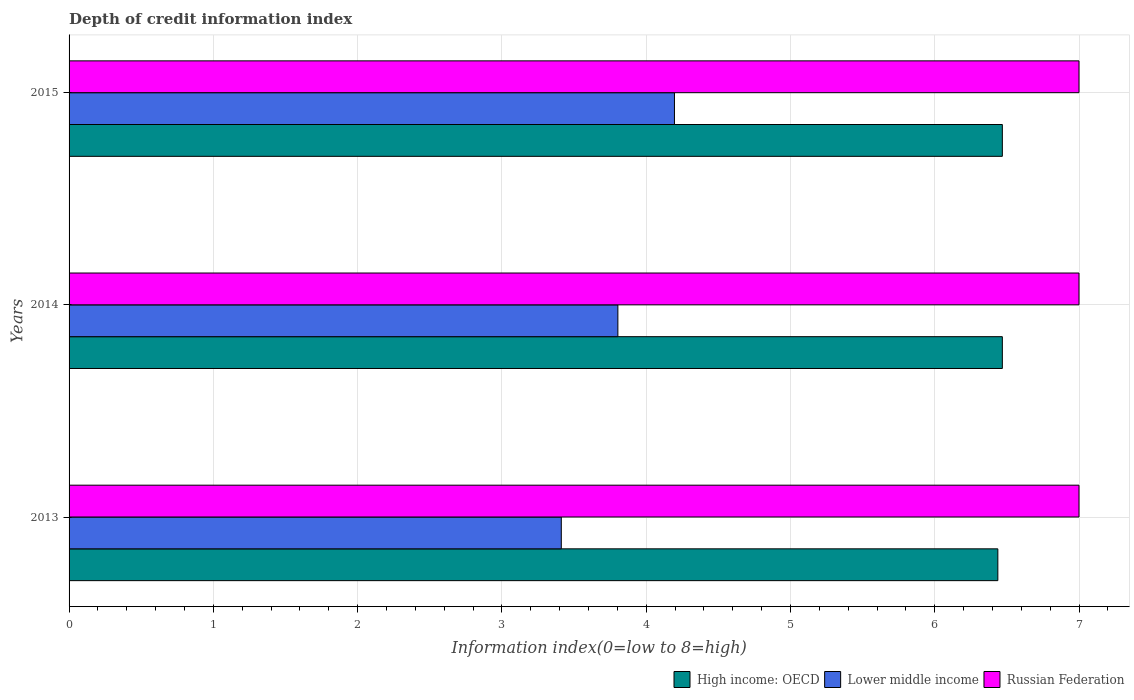How many groups of bars are there?
Provide a short and direct response. 3. Are the number of bars per tick equal to the number of legend labels?
Provide a short and direct response. Yes. Are the number of bars on each tick of the Y-axis equal?
Give a very brief answer. Yes. How many bars are there on the 3rd tick from the top?
Keep it short and to the point. 3. What is the information index in Russian Federation in 2013?
Your answer should be compact. 7. Across all years, what is the maximum information index in High income: OECD?
Keep it short and to the point. 6.47. Across all years, what is the minimum information index in Russian Federation?
Provide a succinct answer. 7. In which year was the information index in Lower middle income maximum?
Ensure brevity in your answer.  2015. In which year was the information index in Russian Federation minimum?
Provide a short and direct response. 2013. What is the total information index in High income: OECD in the graph?
Ensure brevity in your answer.  19.38. What is the difference between the information index in Lower middle income in 2014 and the information index in Russian Federation in 2013?
Your response must be concise. -3.2. What is the average information index in High income: OECD per year?
Keep it short and to the point. 6.46. In the year 2014, what is the difference between the information index in Lower middle income and information index in Russian Federation?
Offer a terse response. -3.2. In how many years, is the information index in High income: OECD greater than 5 ?
Keep it short and to the point. 3. What is the ratio of the information index in High income: OECD in 2013 to that in 2014?
Offer a terse response. 1. What is the difference between the highest and the lowest information index in Lower middle income?
Give a very brief answer. 0.78. What does the 2nd bar from the top in 2014 represents?
Your answer should be compact. Lower middle income. What does the 2nd bar from the bottom in 2013 represents?
Your response must be concise. Lower middle income. How many bars are there?
Ensure brevity in your answer.  9. Are all the bars in the graph horizontal?
Provide a succinct answer. Yes. What is the difference between two consecutive major ticks on the X-axis?
Your answer should be compact. 1. Are the values on the major ticks of X-axis written in scientific E-notation?
Offer a terse response. No. Does the graph contain any zero values?
Provide a short and direct response. No. How many legend labels are there?
Offer a terse response. 3. How are the legend labels stacked?
Give a very brief answer. Horizontal. What is the title of the graph?
Your answer should be compact. Depth of credit information index. Does "Cayman Islands" appear as one of the legend labels in the graph?
Your response must be concise. No. What is the label or title of the X-axis?
Ensure brevity in your answer.  Information index(0=low to 8=high). What is the Information index(0=low to 8=high) in High income: OECD in 2013?
Provide a succinct answer. 6.44. What is the Information index(0=low to 8=high) in Lower middle income in 2013?
Make the answer very short. 3.41. What is the Information index(0=low to 8=high) in High income: OECD in 2014?
Ensure brevity in your answer.  6.47. What is the Information index(0=low to 8=high) in Lower middle income in 2014?
Provide a short and direct response. 3.8. What is the Information index(0=low to 8=high) of Russian Federation in 2014?
Ensure brevity in your answer.  7. What is the Information index(0=low to 8=high) in High income: OECD in 2015?
Give a very brief answer. 6.47. What is the Information index(0=low to 8=high) in Lower middle income in 2015?
Keep it short and to the point. 4.2. Across all years, what is the maximum Information index(0=low to 8=high) in High income: OECD?
Ensure brevity in your answer.  6.47. Across all years, what is the maximum Information index(0=low to 8=high) of Lower middle income?
Keep it short and to the point. 4.2. Across all years, what is the maximum Information index(0=low to 8=high) in Russian Federation?
Keep it short and to the point. 7. Across all years, what is the minimum Information index(0=low to 8=high) of High income: OECD?
Your answer should be very brief. 6.44. Across all years, what is the minimum Information index(0=low to 8=high) of Lower middle income?
Offer a very short reply. 3.41. Across all years, what is the minimum Information index(0=low to 8=high) of Russian Federation?
Provide a succinct answer. 7. What is the total Information index(0=low to 8=high) of High income: OECD in the graph?
Give a very brief answer. 19.38. What is the total Information index(0=low to 8=high) in Lower middle income in the graph?
Provide a short and direct response. 11.41. What is the total Information index(0=low to 8=high) in Russian Federation in the graph?
Ensure brevity in your answer.  21. What is the difference between the Information index(0=low to 8=high) in High income: OECD in 2013 and that in 2014?
Make the answer very short. -0.03. What is the difference between the Information index(0=low to 8=high) of Lower middle income in 2013 and that in 2014?
Your answer should be compact. -0.39. What is the difference between the Information index(0=low to 8=high) in Russian Federation in 2013 and that in 2014?
Offer a terse response. 0. What is the difference between the Information index(0=low to 8=high) of High income: OECD in 2013 and that in 2015?
Offer a very short reply. -0.03. What is the difference between the Information index(0=low to 8=high) of Lower middle income in 2013 and that in 2015?
Your answer should be compact. -0.78. What is the difference between the Information index(0=low to 8=high) of Russian Federation in 2013 and that in 2015?
Keep it short and to the point. 0. What is the difference between the Information index(0=low to 8=high) in Lower middle income in 2014 and that in 2015?
Your answer should be compact. -0.39. What is the difference between the Information index(0=low to 8=high) in High income: OECD in 2013 and the Information index(0=low to 8=high) in Lower middle income in 2014?
Your answer should be compact. 2.63. What is the difference between the Information index(0=low to 8=high) in High income: OECD in 2013 and the Information index(0=low to 8=high) in Russian Federation in 2014?
Your answer should be compact. -0.56. What is the difference between the Information index(0=low to 8=high) in Lower middle income in 2013 and the Information index(0=low to 8=high) in Russian Federation in 2014?
Ensure brevity in your answer.  -3.59. What is the difference between the Information index(0=low to 8=high) in High income: OECD in 2013 and the Information index(0=low to 8=high) in Lower middle income in 2015?
Provide a short and direct response. 2.24. What is the difference between the Information index(0=low to 8=high) in High income: OECD in 2013 and the Information index(0=low to 8=high) in Russian Federation in 2015?
Your answer should be compact. -0.56. What is the difference between the Information index(0=low to 8=high) in Lower middle income in 2013 and the Information index(0=low to 8=high) in Russian Federation in 2015?
Ensure brevity in your answer.  -3.59. What is the difference between the Information index(0=low to 8=high) in High income: OECD in 2014 and the Information index(0=low to 8=high) in Lower middle income in 2015?
Your answer should be compact. 2.27. What is the difference between the Information index(0=low to 8=high) of High income: OECD in 2014 and the Information index(0=low to 8=high) of Russian Federation in 2015?
Provide a short and direct response. -0.53. What is the difference between the Information index(0=low to 8=high) of Lower middle income in 2014 and the Information index(0=low to 8=high) of Russian Federation in 2015?
Keep it short and to the point. -3.2. What is the average Information index(0=low to 8=high) of High income: OECD per year?
Provide a succinct answer. 6.46. What is the average Information index(0=low to 8=high) of Lower middle income per year?
Make the answer very short. 3.8. In the year 2013, what is the difference between the Information index(0=low to 8=high) in High income: OECD and Information index(0=low to 8=high) in Lower middle income?
Provide a short and direct response. 3.03. In the year 2013, what is the difference between the Information index(0=low to 8=high) of High income: OECD and Information index(0=low to 8=high) of Russian Federation?
Offer a terse response. -0.56. In the year 2013, what is the difference between the Information index(0=low to 8=high) of Lower middle income and Information index(0=low to 8=high) of Russian Federation?
Provide a succinct answer. -3.59. In the year 2014, what is the difference between the Information index(0=low to 8=high) in High income: OECD and Information index(0=low to 8=high) in Lower middle income?
Your answer should be very brief. 2.66. In the year 2014, what is the difference between the Information index(0=low to 8=high) of High income: OECD and Information index(0=low to 8=high) of Russian Federation?
Your answer should be very brief. -0.53. In the year 2014, what is the difference between the Information index(0=low to 8=high) of Lower middle income and Information index(0=low to 8=high) of Russian Federation?
Provide a succinct answer. -3.2. In the year 2015, what is the difference between the Information index(0=low to 8=high) in High income: OECD and Information index(0=low to 8=high) in Lower middle income?
Offer a terse response. 2.27. In the year 2015, what is the difference between the Information index(0=low to 8=high) of High income: OECD and Information index(0=low to 8=high) of Russian Federation?
Your answer should be compact. -0.53. In the year 2015, what is the difference between the Information index(0=low to 8=high) in Lower middle income and Information index(0=low to 8=high) in Russian Federation?
Provide a succinct answer. -2.8. What is the ratio of the Information index(0=low to 8=high) of High income: OECD in 2013 to that in 2014?
Provide a succinct answer. 1. What is the ratio of the Information index(0=low to 8=high) of Lower middle income in 2013 to that in 2014?
Your response must be concise. 0.9. What is the ratio of the Information index(0=low to 8=high) of Russian Federation in 2013 to that in 2014?
Keep it short and to the point. 1. What is the ratio of the Information index(0=low to 8=high) of High income: OECD in 2013 to that in 2015?
Keep it short and to the point. 1. What is the ratio of the Information index(0=low to 8=high) of Lower middle income in 2013 to that in 2015?
Make the answer very short. 0.81. What is the ratio of the Information index(0=low to 8=high) of Russian Federation in 2013 to that in 2015?
Provide a short and direct response. 1. What is the ratio of the Information index(0=low to 8=high) in Lower middle income in 2014 to that in 2015?
Offer a very short reply. 0.91. What is the difference between the highest and the second highest Information index(0=low to 8=high) in High income: OECD?
Your answer should be compact. 0. What is the difference between the highest and the second highest Information index(0=low to 8=high) in Lower middle income?
Offer a very short reply. 0.39. What is the difference between the highest and the second highest Information index(0=low to 8=high) of Russian Federation?
Ensure brevity in your answer.  0. What is the difference between the highest and the lowest Information index(0=low to 8=high) of High income: OECD?
Keep it short and to the point. 0.03. What is the difference between the highest and the lowest Information index(0=low to 8=high) in Lower middle income?
Keep it short and to the point. 0.78. What is the difference between the highest and the lowest Information index(0=low to 8=high) of Russian Federation?
Keep it short and to the point. 0. 